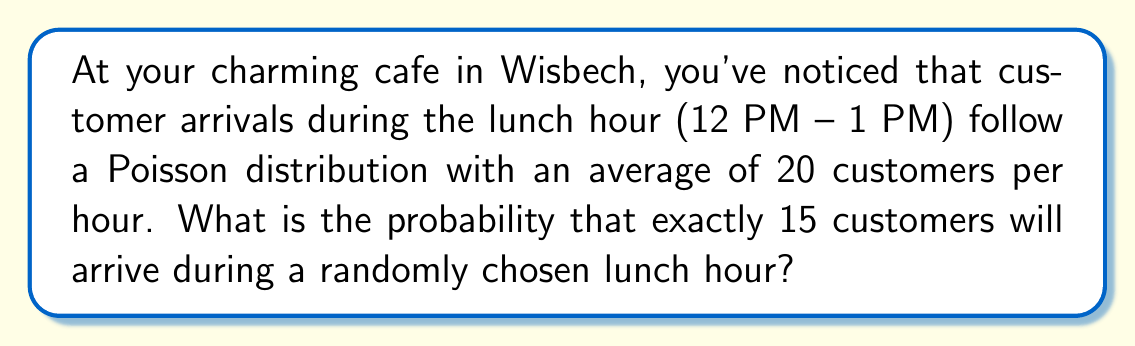Provide a solution to this math problem. To solve this problem, we'll use the Poisson distribution formula:

$$P(X = k) = \frac{e^{-\lambda} \lambda^k}{k!}$$

Where:
$\lambda$ = average number of events in the interval
$k$ = number of events we're calculating the probability for
$e$ = Euler's number (approximately 2.71828)

Given:
$\lambda = 20$ (average customers per hour)
$k = 15$ (number of customers we're calculating the probability for)

Let's substitute these values into the formula:

$$P(X = 15) = \frac{e^{-20} 20^{15}}{15!}$$

Now, let's calculate this step-by-step:

1) First, calculate $e^{-20}$:
   $e^{-20} \approx 2.061153622 \times 10^{-9}$

2) Calculate $20^{15}$:
   $20^{15} = 3.2768 \times 10^{19}$

3) Calculate 15!:
   $15! = 1307674368000$

4) Now, put it all together:

   $$\frac{(2.061153622 \times 10^{-9})(3.2768 \times 10^{19})}{1307674368000}$$

5) Simplify:
   $$\frac{6.753910436 \times 10^{10}}{1307674368000} \approx 0.0516$$

Therefore, the probability of exactly 15 customers arriving during a randomly chosen lunch hour is approximately 0.0516 or 5.16%.
Answer: 0.0516 or 5.16% 